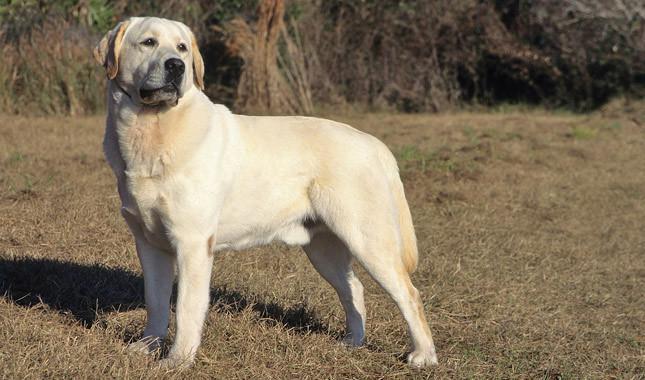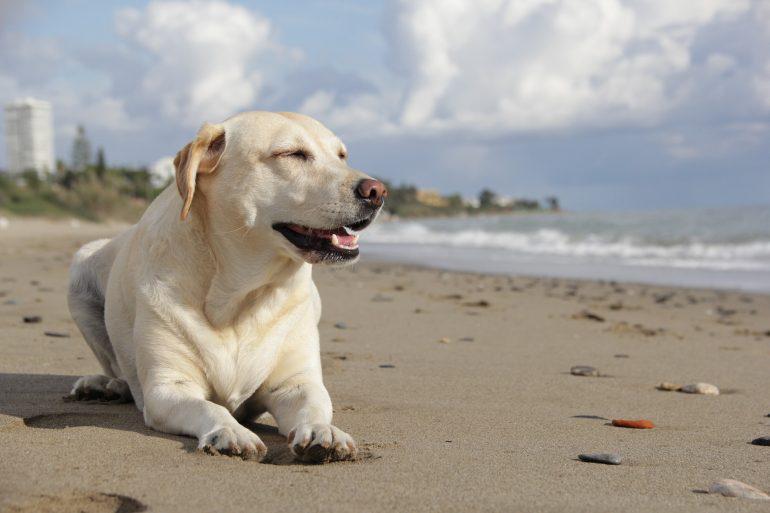The first image is the image on the left, the second image is the image on the right. Assess this claim about the two images: "At least one dog has a green tennis ball.". Correct or not? Answer yes or no. No. 